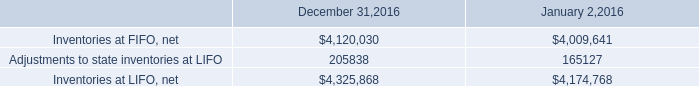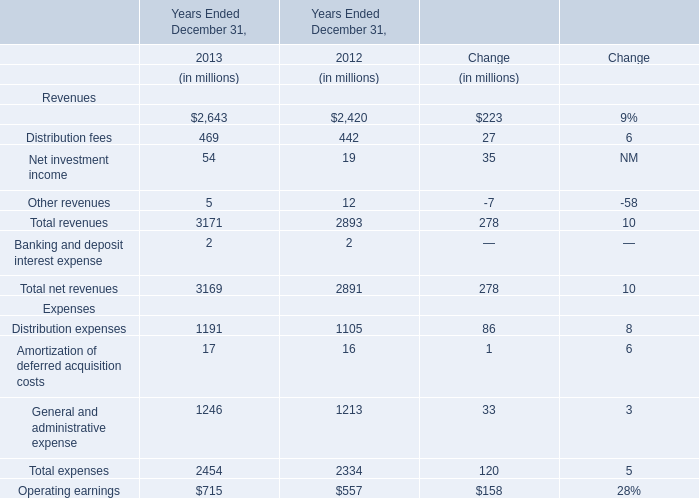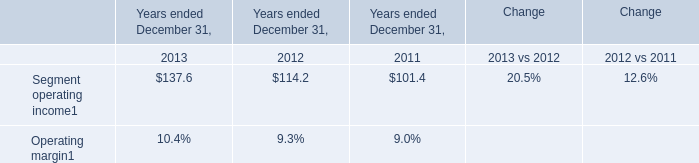What is the proportion of Distribution fees to the total in 2013? 
Computations: (469 / 3171)
Answer: 0.1479. 